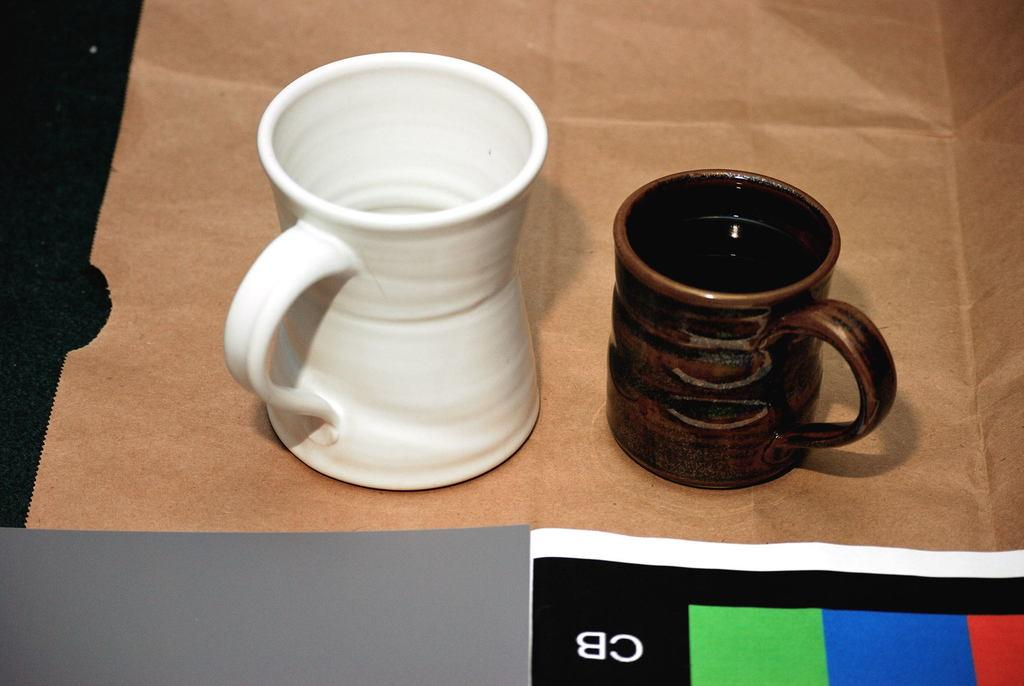<image>
Write a terse but informative summary of the picture. Two coffee cups sitting on top of a paper bag with a paper showing a CB logo near them. 